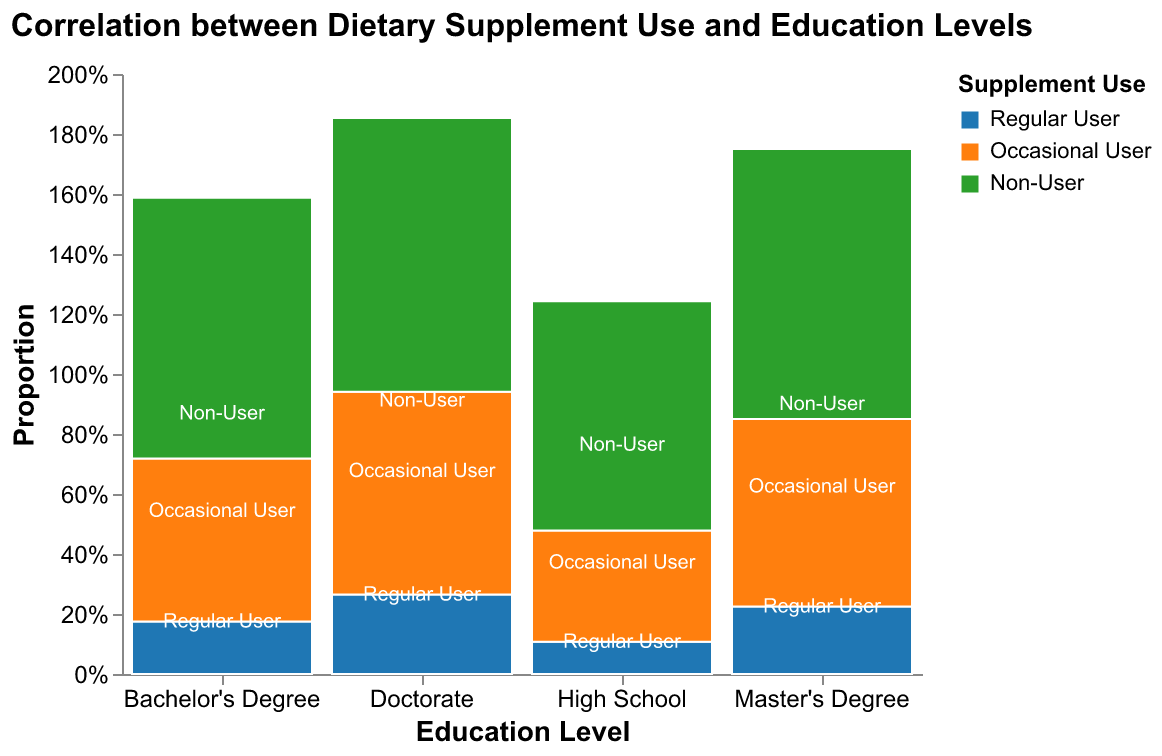What's the title of the figure? The title of the figure is displayed at the top.
Answer: Correlation between Dietary Supplement Use and Education Levels What are the three categories of "Supplement Use" displayed in the figure? The categories are shown in the legend and represented by different colors in the plot.
Answer: Regular User, Occasional User, Non-User Which education level has the highest proportion of "Regular Users"? By comparing the height of the "Regular User" segment for each education level, we see which one is tallest.
Answer: Bachelor's Degree Compare the proportion of "Non-Users" with a Bachelor's Degree to those with a High School education. Look at the heights of the "Non-User" segments for both education levels and compare them.
Answer: The proportion of "Non-Users" is higher for High School What is the total proportion of users (both Regular and Occasional) for those with a Master's Degree? To find this, add the proportions of "Regular Users" and "Occasional Users" in the Master's Degree category.
Answer: 80% How does the proportion of "Occasional Users" in the Doctorate category compare to the "Regular Users" in the same category? Compare the height of the "Occasional Users" segment to the "Regular Users" segment within the Doctorate category.
Answer: Lower Which education level shows the smallest proportion of "Non-Users"? By comparing the smallest "Non-User" segment across all education levels, determine which is the smallest.
Answer: Doctorate How does the proportion of "Regular Users" in the Bachelor's Degree category compare to the "Regular Users" in the Master's Degree category? Look at the heights of the "Regular Users" segments for both categories and compare them.
Answer: Higher for Bachelor's Degree 